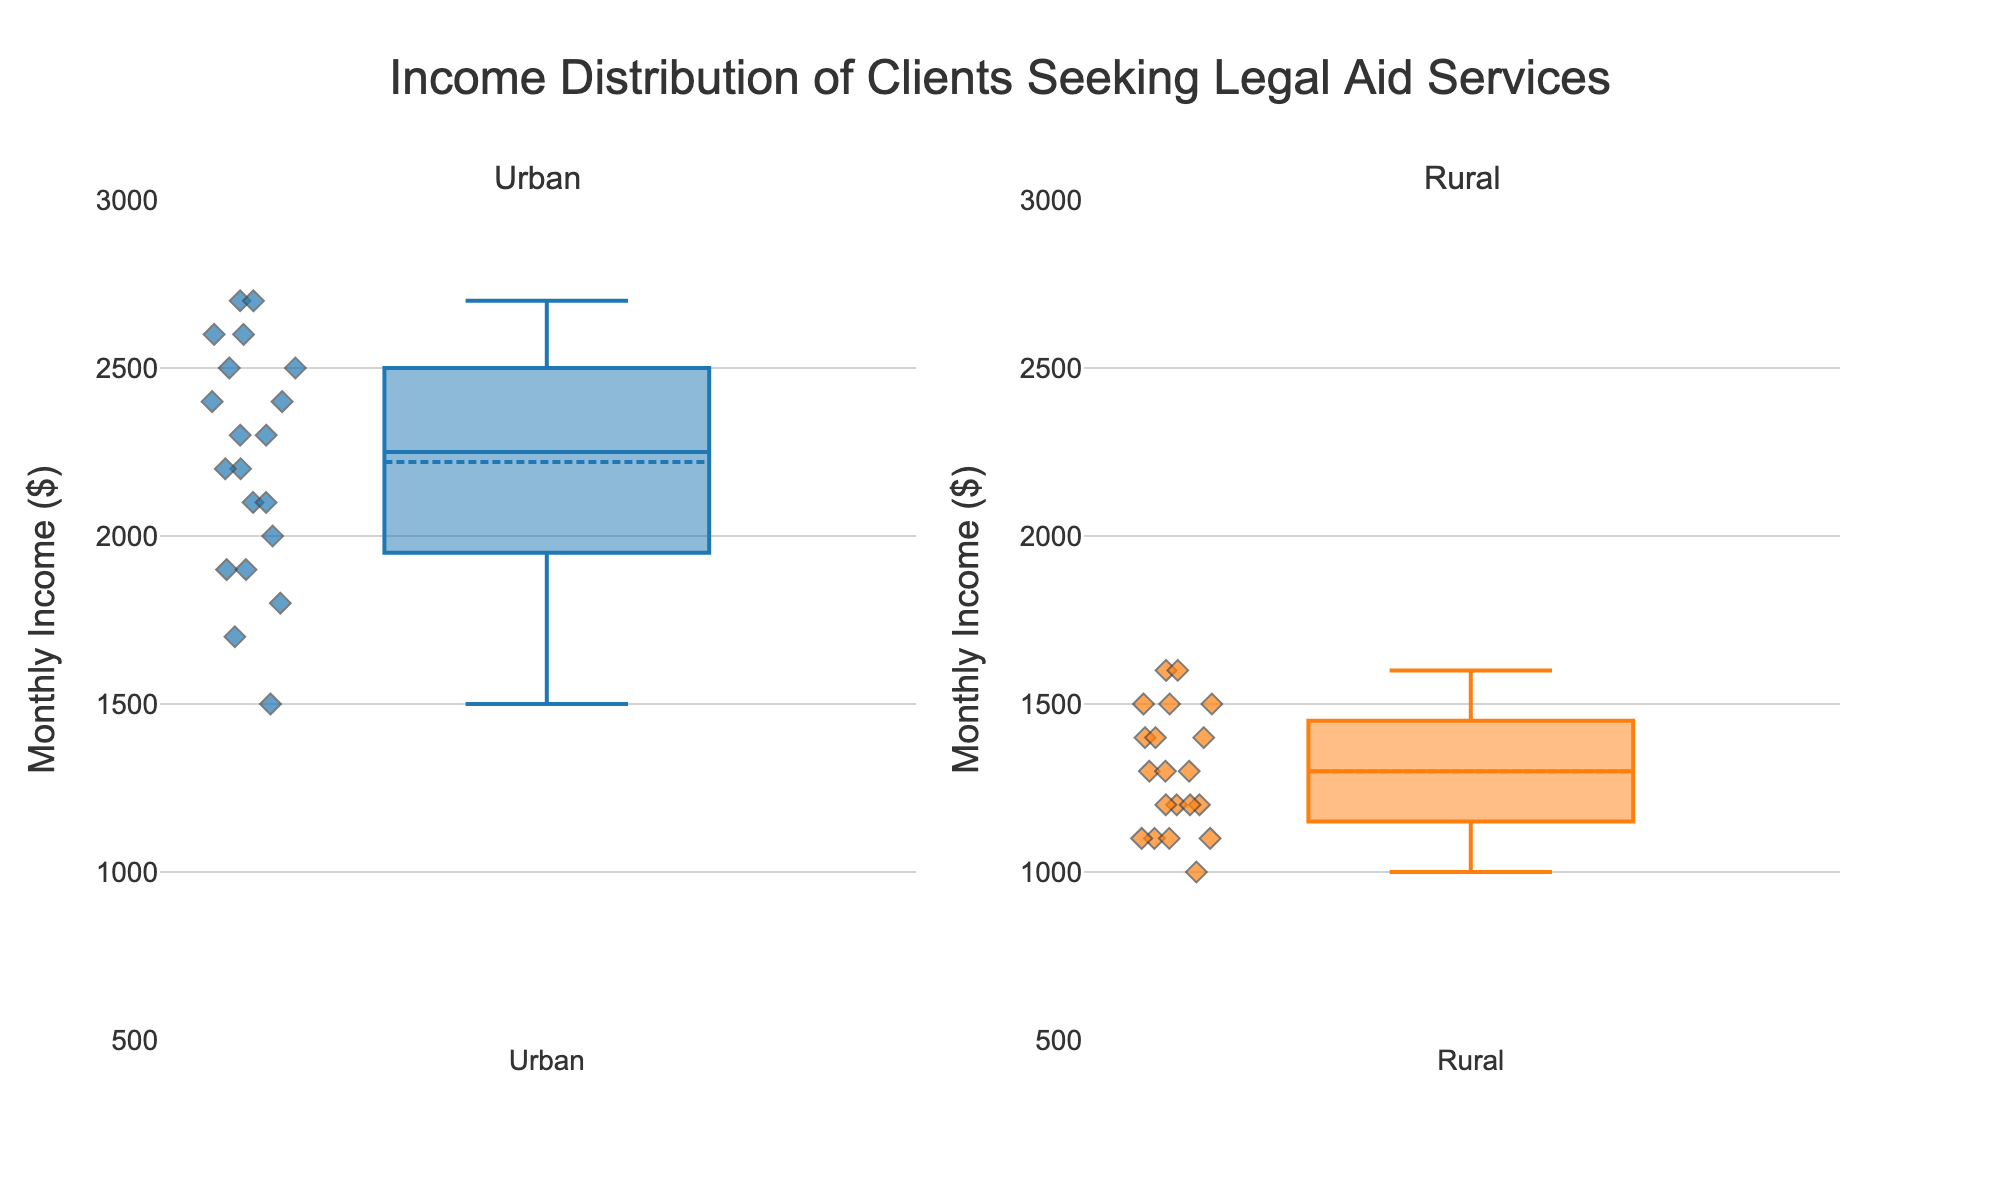which area has a higher median monthly income? The median is the middle value in each box plot. The box plot for the Urban area has its median (the line inside the box) higher than that of the Rural area.
Answer: Urban what is the title of the figure? The title of the figure is usually displayed at the top and here it reads, "Income Distribution of Clients Seeking Legal Aid Services."
Answer: Income Distribution of Clients Seeking Legal Aid Services which area has a greater range of monthly incomes? The range is the difference between the maximum and minimum values in each box plot. The Urban area box plot spans from around 1500 to 2700, whereas the Rural area spans from 1000 to 1600. Urban has a greater range.
Answer: Urban how do the interquartile ranges (IQR) of Urban and Rural areas compare? IQR is the range between the first quartile (Q1) and third quartile (Q3). The Urban area has a larger IQR, as its box is considerably wider than that of the Rural area.
Answer: Urban has a larger IQR what is the approximate monthly income range for rural clients seeking legal aid? The box plot for Rural shows data points from around 1000 to 1600, marking the minimum and maximum ranges.
Answer: 1000 to 1600 which area shows more variation in monthly incomes? Variation can be observed by the spread of the data points and the box width. The Urban area shows more variation, with a wider box and broader spread of data points.
Answer: Urban does the urban or rural area have a higher mean monthly income? The mean is shown by the dashed line inside each box plot. The Urban area has its mean line higher than the Rural area’s mean line.
Answer: Urban are there outliers in the rural area plot? Outliers generally appear as individual points outside the main box and whiskers. The Rural plot does not show any outliers.
Answer: No compare the upper whisker lengths for urban and rural areas. The upper whisker extends from the top of the box to the maximum value within 1.5 times the IQR. The Urban area has a longer upper whisker compared to the Rural area.
Answer: Urban has a longer upper whisker how many clients are represented in each area based on the box plots? The total number of data points (clients) is 20 in both the Urban and Rural areas, which can be estimated by the number of dots around each box plot.
Answer: 20 Urban, 20 Rural 